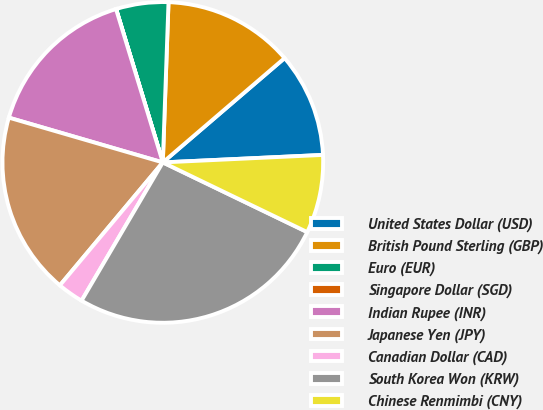Convert chart to OTSL. <chart><loc_0><loc_0><loc_500><loc_500><pie_chart><fcel>United States Dollar (USD)<fcel>British Pound Sterling (GBP)<fcel>Euro (EUR)<fcel>Singapore Dollar (SGD)<fcel>Indian Rupee (INR)<fcel>Japanese Yen (JPY)<fcel>Canadian Dollar (CAD)<fcel>South Korea Won (KRW)<fcel>Chinese Renmimbi (CNY)<nl><fcel>10.53%<fcel>13.16%<fcel>5.27%<fcel>0.01%<fcel>15.78%<fcel>18.41%<fcel>2.64%<fcel>26.3%<fcel>7.9%<nl></chart> 